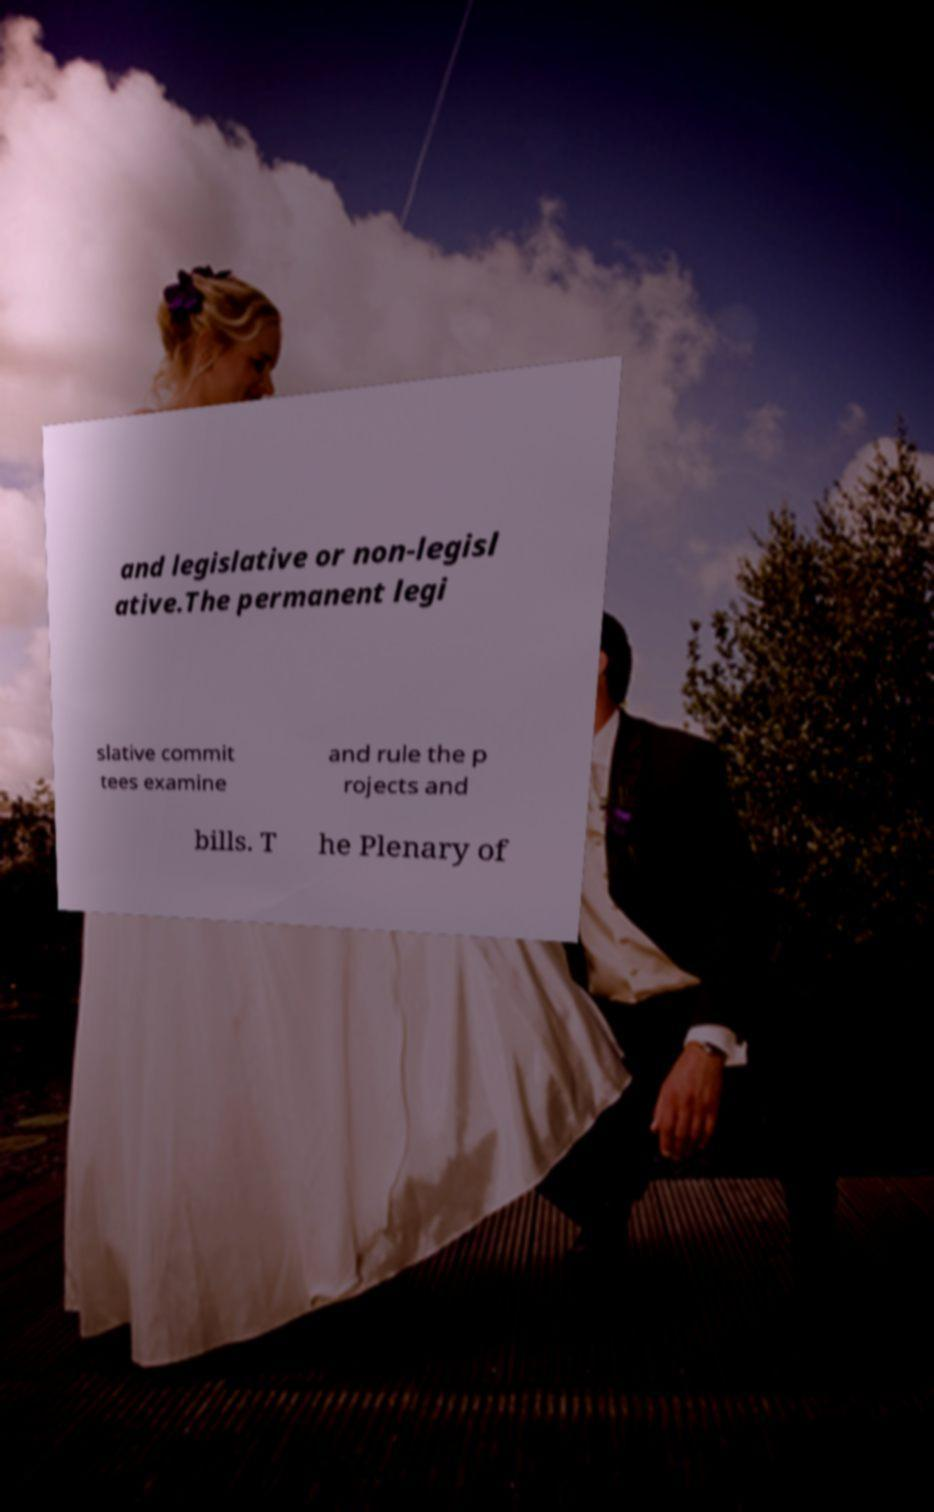I need the written content from this picture converted into text. Can you do that? and legislative or non-legisl ative.The permanent legi slative commit tees examine and rule the p rojects and bills. T he Plenary of 